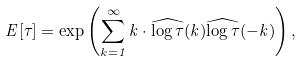Convert formula to latex. <formula><loc_0><loc_0><loc_500><loc_500>E [ \tau ] = \exp \left ( \sum _ { k = 1 } ^ { \infty } k \cdot \widehat { \log \tau } ( k ) \widehat { \log \tau } ( - k ) \right ) ,</formula> 